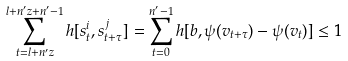Convert formula to latex. <formula><loc_0><loc_0><loc_500><loc_500>\sum _ { t = l + n ^ { \prime } z } ^ { l + n ^ { \prime } z + n ^ { \prime } - 1 } h [ s _ { t } ^ { i } , s _ { t + \tau } ^ { j } ] = \sum _ { t = 0 } ^ { n ^ { \prime } - 1 } h [ b , \psi ( v _ { t + \tau } ) - \psi ( v _ { t } ) ] \leq 1</formula> 